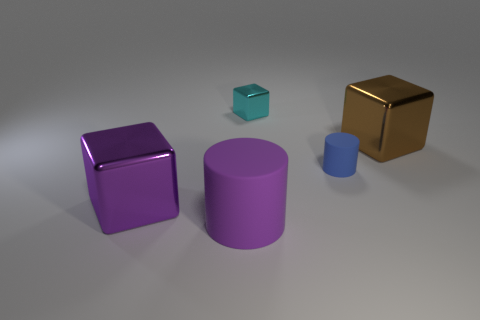There is a large thing that is the same shape as the tiny blue object; what is it made of?
Your answer should be very brief. Rubber. There is a large purple thing right of the large block that is in front of the brown shiny block; how many big rubber cylinders are to the left of it?
Your answer should be compact. 0. Are there any other things that are the same color as the tiny cylinder?
Your response must be concise. No. What number of large objects are both behind the purple rubber thing and in front of the tiny blue rubber thing?
Provide a short and direct response. 1. Do the cube left of the big purple cylinder and the matte cylinder in front of the purple block have the same size?
Your response must be concise. Yes. How many objects are matte objects right of the big purple rubber cylinder or shiny blocks?
Your answer should be very brief. 4. What material is the purple object behind the large purple rubber thing?
Your answer should be very brief. Metal. What material is the big purple block?
Ensure brevity in your answer.  Metal. What material is the cylinder that is behind the block that is in front of the object on the right side of the tiny blue thing?
Your response must be concise. Rubber. There is a purple metal cube; does it have the same size as the purple rubber object that is in front of the large purple metallic thing?
Provide a short and direct response. Yes. 